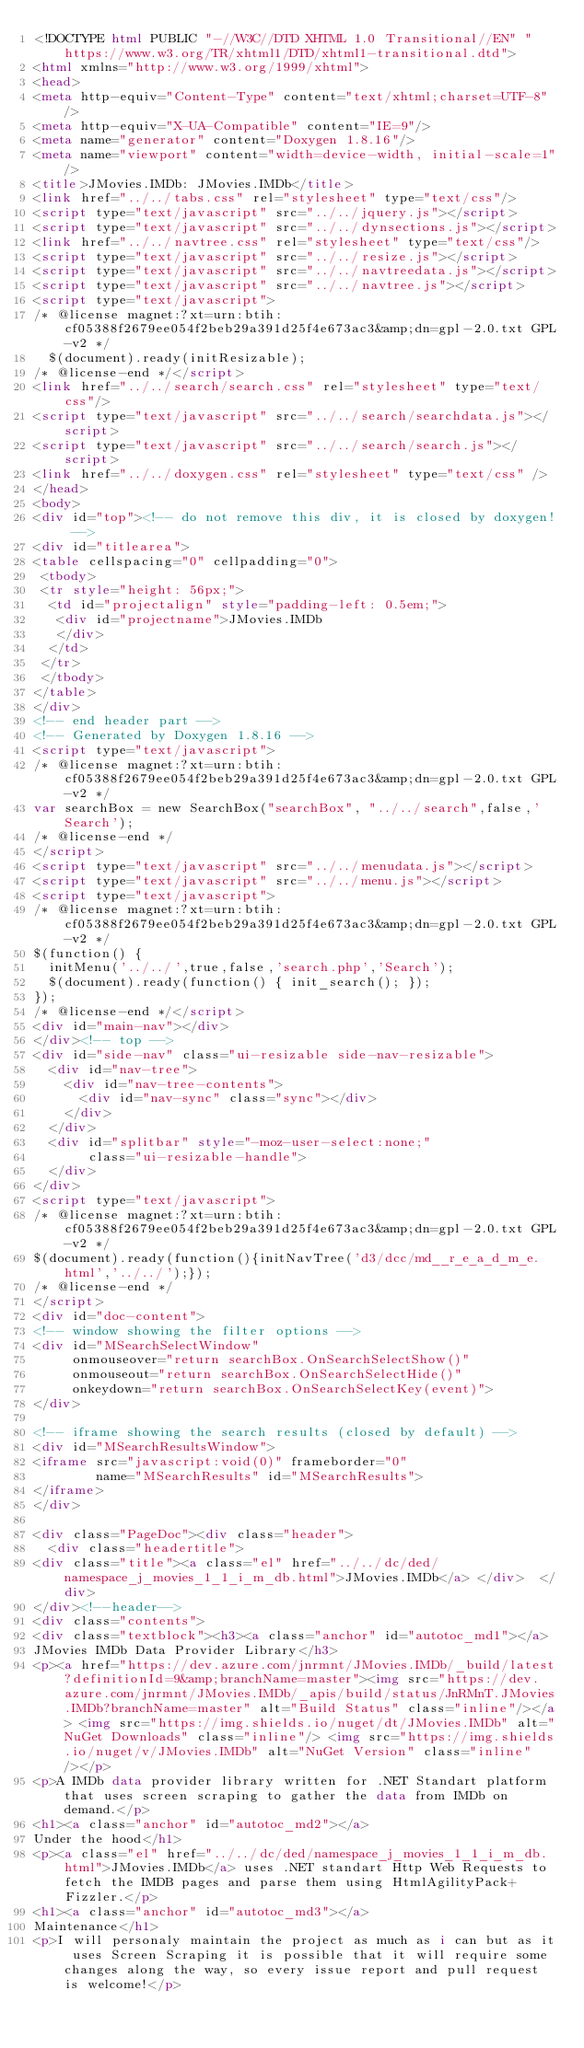Convert code to text. <code><loc_0><loc_0><loc_500><loc_500><_HTML_><!DOCTYPE html PUBLIC "-//W3C//DTD XHTML 1.0 Transitional//EN" "https://www.w3.org/TR/xhtml1/DTD/xhtml1-transitional.dtd">
<html xmlns="http://www.w3.org/1999/xhtml">
<head>
<meta http-equiv="Content-Type" content="text/xhtml;charset=UTF-8"/>
<meta http-equiv="X-UA-Compatible" content="IE=9"/>
<meta name="generator" content="Doxygen 1.8.16"/>
<meta name="viewport" content="width=device-width, initial-scale=1"/>
<title>JMovies.IMDb: JMovies.IMDb</title>
<link href="../../tabs.css" rel="stylesheet" type="text/css"/>
<script type="text/javascript" src="../../jquery.js"></script>
<script type="text/javascript" src="../../dynsections.js"></script>
<link href="../../navtree.css" rel="stylesheet" type="text/css"/>
<script type="text/javascript" src="../../resize.js"></script>
<script type="text/javascript" src="../../navtreedata.js"></script>
<script type="text/javascript" src="../../navtree.js"></script>
<script type="text/javascript">
/* @license magnet:?xt=urn:btih:cf05388f2679ee054f2beb29a391d25f4e673ac3&amp;dn=gpl-2.0.txt GPL-v2 */
  $(document).ready(initResizable);
/* @license-end */</script>
<link href="../../search/search.css" rel="stylesheet" type="text/css"/>
<script type="text/javascript" src="../../search/searchdata.js"></script>
<script type="text/javascript" src="../../search/search.js"></script>
<link href="../../doxygen.css" rel="stylesheet" type="text/css" />
</head>
<body>
<div id="top"><!-- do not remove this div, it is closed by doxygen! -->
<div id="titlearea">
<table cellspacing="0" cellpadding="0">
 <tbody>
 <tr style="height: 56px;">
  <td id="projectalign" style="padding-left: 0.5em;">
   <div id="projectname">JMovies.IMDb
   </div>
  </td>
 </tr>
 </tbody>
</table>
</div>
<!-- end header part -->
<!-- Generated by Doxygen 1.8.16 -->
<script type="text/javascript">
/* @license magnet:?xt=urn:btih:cf05388f2679ee054f2beb29a391d25f4e673ac3&amp;dn=gpl-2.0.txt GPL-v2 */
var searchBox = new SearchBox("searchBox", "../../search",false,'Search');
/* @license-end */
</script>
<script type="text/javascript" src="../../menudata.js"></script>
<script type="text/javascript" src="../../menu.js"></script>
<script type="text/javascript">
/* @license magnet:?xt=urn:btih:cf05388f2679ee054f2beb29a391d25f4e673ac3&amp;dn=gpl-2.0.txt GPL-v2 */
$(function() {
  initMenu('../../',true,false,'search.php','Search');
  $(document).ready(function() { init_search(); });
});
/* @license-end */</script>
<div id="main-nav"></div>
</div><!-- top -->
<div id="side-nav" class="ui-resizable side-nav-resizable">
  <div id="nav-tree">
    <div id="nav-tree-contents">
      <div id="nav-sync" class="sync"></div>
    </div>
  </div>
  <div id="splitbar" style="-moz-user-select:none;" 
       class="ui-resizable-handle">
  </div>
</div>
<script type="text/javascript">
/* @license magnet:?xt=urn:btih:cf05388f2679ee054f2beb29a391d25f4e673ac3&amp;dn=gpl-2.0.txt GPL-v2 */
$(document).ready(function(){initNavTree('d3/dcc/md__r_e_a_d_m_e.html','../../');});
/* @license-end */
</script>
<div id="doc-content">
<!-- window showing the filter options -->
<div id="MSearchSelectWindow"
     onmouseover="return searchBox.OnSearchSelectShow()"
     onmouseout="return searchBox.OnSearchSelectHide()"
     onkeydown="return searchBox.OnSearchSelectKey(event)">
</div>

<!-- iframe showing the search results (closed by default) -->
<div id="MSearchResultsWindow">
<iframe src="javascript:void(0)" frameborder="0" 
        name="MSearchResults" id="MSearchResults">
</iframe>
</div>

<div class="PageDoc"><div class="header">
  <div class="headertitle">
<div class="title"><a class="el" href="../../dc/ded/namespace_j_movies_1_1_i_m_db.html">JMovies.IMDb</a> </div>  </div>
</div><!--header-->
<div class="contents">
<div class="textblock"><h3><a class="anchor" id="autotoc_md1"></a>
JMovies IMDb Data Provider Library</h3>
<p><a href="https://dev.azure.com/jnrmnt/JMovies.IMDb/_build/latest?definitionId=9&amp;branchName=master"><img src="https://dev.azure.com/jnrmnt/JMovies.IMDb/_apis/build/status/JnRMnT.JMovies.IMDb?branchName=master" alt="Build Status" class="inline"/></a> <img src="https://img.shields.io/nuget/dt/JMovies.IMDb" alt="NuGet Downloads" class="inline"/> <img src="https://img.shields.io/nuget/v/JMovies.IMDb" alt="NuGet Version" class="inline"/></p>
<p>A IMDb data provider library written for .NET Standart platform that uses screen scraping to gather the data from IMDb on demand.</p>
<h1><a class="anchor" id="autotoc_md2"></a>
Under the hood</h1>
<p><a class="el" href="../../dc/ded/namespace_j_movies_1_1_i_m_db.html">JMovies.IMDb</a> uses .NET standart Http Web Requests to fetch the IMDB pages and parse them using HtmlAgilityPack+Fizzler.</p>
<h1><a class="anchor" id="autotoc_md3"></a>
Maintenance</h1>
<p>I will personaly maintain the project as much as i can but as it uses Screen Scraping it is possible that it will require some changes along the way, so every issue report and pull request is welcome!</p></code> 